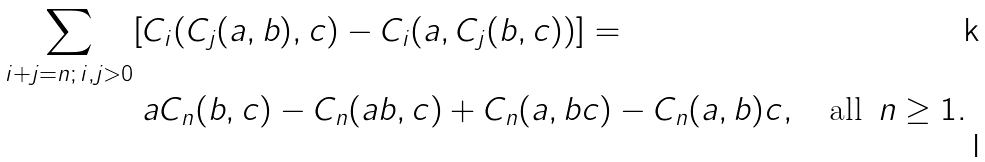Convert formula to latex. <formula><loc_0><loc_0><loc_500><loc_500>\sum _ { i + j = n ; \, i , j > 0 } [ & C _ { i } ( C _ { j } ( a , b ) , c ) - C _ { i } ( a , C _ { j } ( b , c ) ) ] = \\ & a C _ { n } ( b , c ) - C _ { n } ( a b , c ) + C _ { n } ( a , b c ) - C _ { n } ( a , b ) c , \quad \text {all } \, n \geq 1 .</formula> 